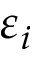Convert formula to latex. <formula><loc_0><loc_0><loc_500><loc_500>\varepsilon _ { i }</formula> 